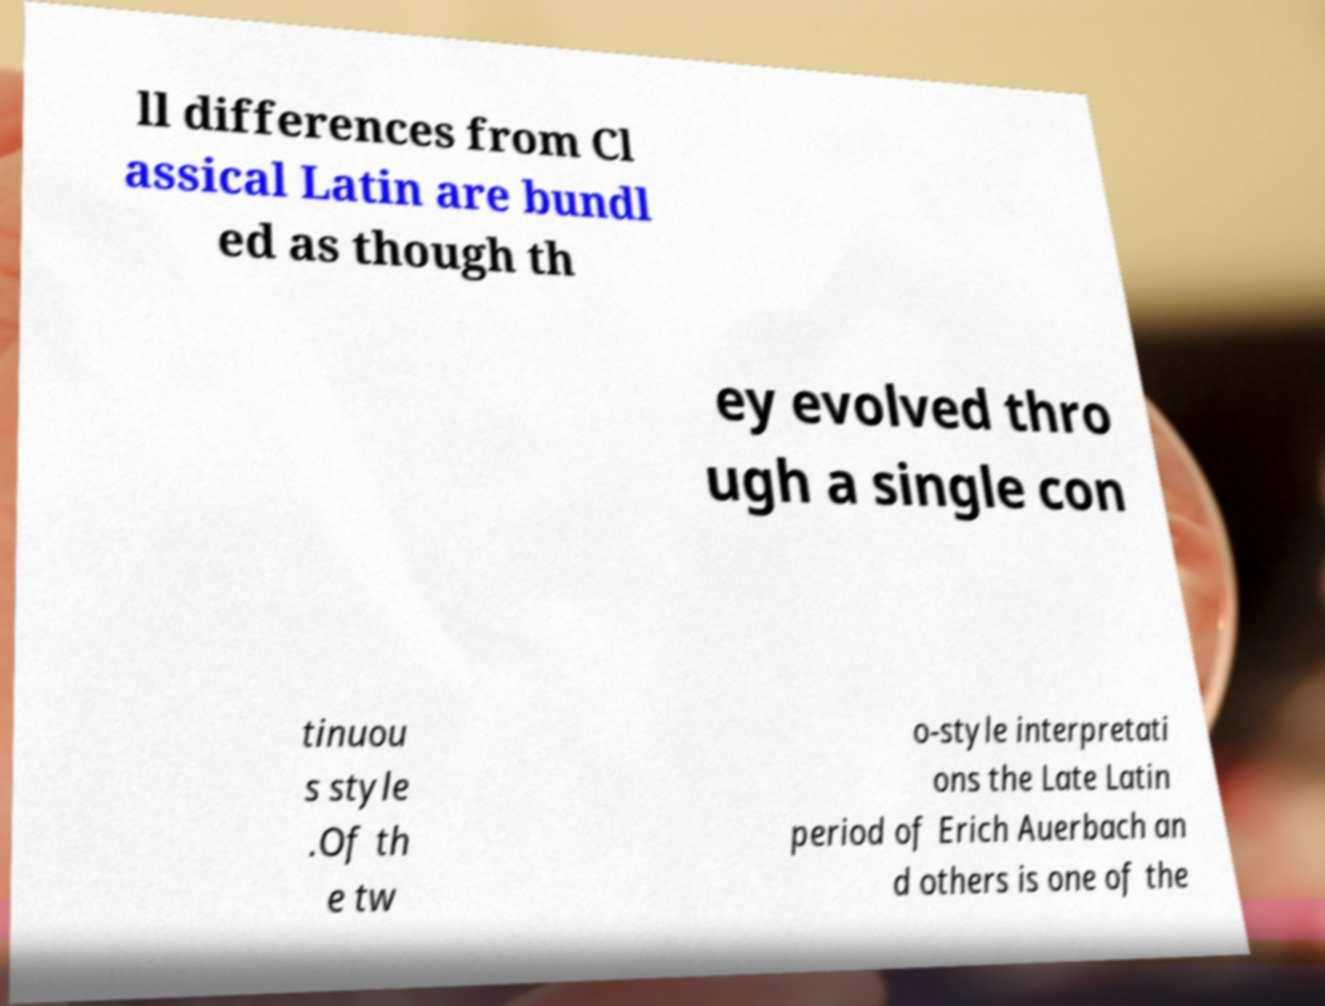Could you assist in decoding the text presented in this image and type it out clearly? ll differences from Cl assical Latin are bundl ed as though th ey evolved thro ugh a single con tinuou s style .Of th e tw o-style interpretati ons the Late Latin period of Erich Auerbach an d others is one of the 